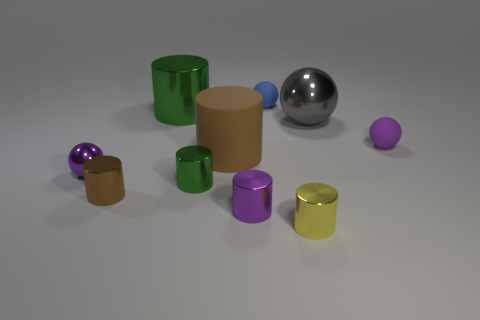Subtract all tiny balls. How many balls are left? 1 Subtract 1 balls. How many balls are left? 3 Subtract all gray balls. How many balls are left? 3 Subtract all balls. How many objects are left? 6 Subtract all cyan cylinders. Subtract all gray spheres. How many cylinders are left? 6 Subtract all gray cubes. How many purple spheres are left? 2 Subtract all purple metallic balls. Subtract all tiny purple metallic cylinders. How many objects are left? 8 Add 7 blue rubber spheres. How many blue rubber spheres are left? 8 Add 5 red metal things. How many red metal things exist? 5 Subtract 0 blue cylinders. How many objects are left? 10 